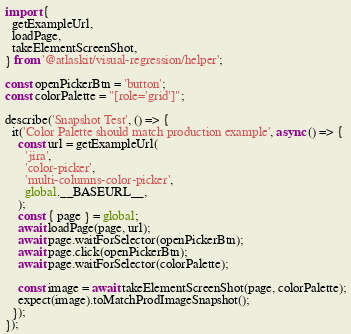<code> <loc_0><loc_0><loc_500><loc_500><_TypeScript_>import {
  getExampleUrl,
  loadPage,
  takeElementScreenShot,
} from '@atlaskit/visual-regression/helper';

const openPickerBtn = 'button';
const colorPalette = "[role='grid']";

describe('Snapshot Test', () => {
  it('Color Palette should match production example', async () => {
    const url = getExampleUrl(
      'jira',
      'color-picker',
      'multi-columns-color-picker',
      global.__BASEURL__,
    );
    const { page } = global;
    await loadPage(page, url);
    await page.waitForSelector(openPickerBtn);
    await page.click(openPickerBtn);
    await page.waitForSelector(colorPalette);

    const image = await takeElementScreenShot(page, colorPalette);
    expect(image).toMatchProdImageSnapshot();
  });
});
</code> 